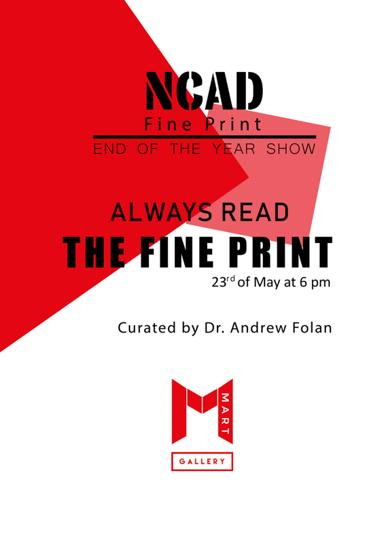Can you describe the design of the poster? The design of the poster is striking, with a bold red and white color scheme that commands attention. The typography is sleek and modern, perfectly framing the event details against the vivid background. 